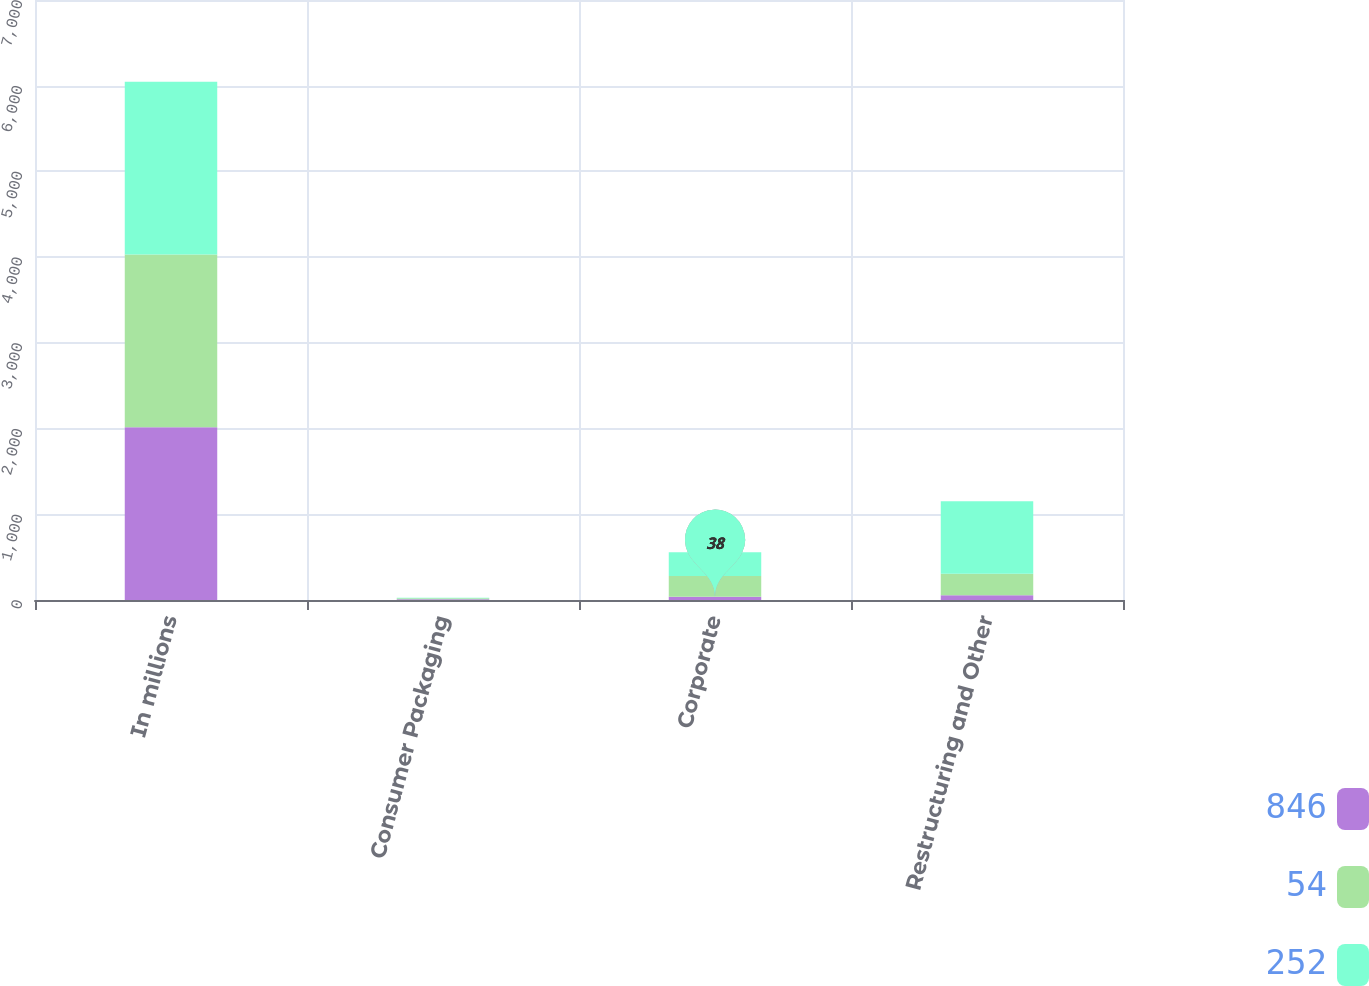Convert chart to OTSL. <chart><loc_0><loc_0><loc_500><loc_500><stacked_bar_chart><ecel><fcel>In millions<fcel>Consumer Packaging<fcel>Corporate<fcel>Restructuring and Other<nl><fcel>846<fcel>2016<fcel>9<fcel>38<fcel>54<nl><fcel>54<fcel>2015<fcel>10<fcel>242<fcel>252<nl><fcel>252<fcel>2014<fcel>8<fcel>277<fcel>846<nl></chart> 